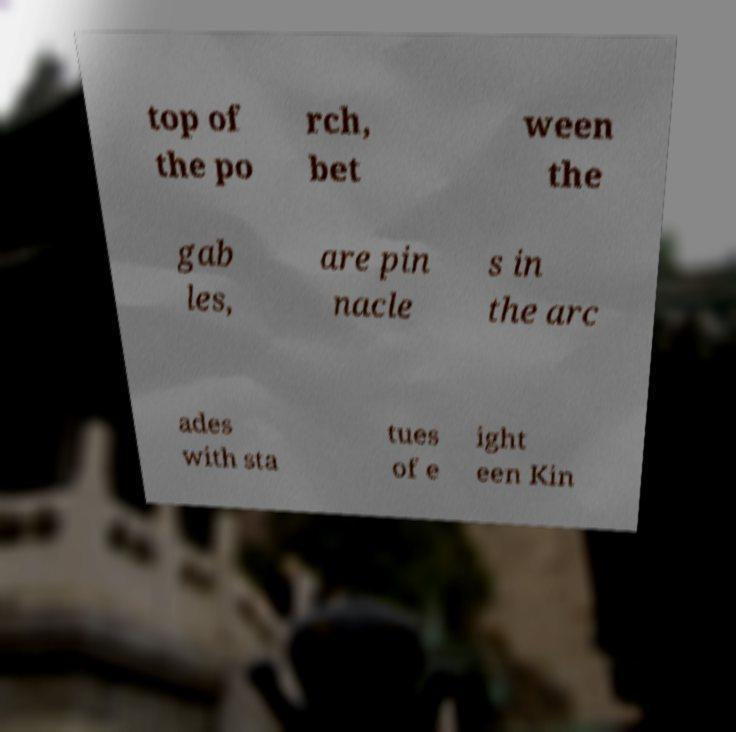For documentation purposes, I need the text within this image transcribed. Could you provide that? top of the po rch, bet ween the gab les, are pin nacle s in the arc ades with sta tues of e ight een Kin 